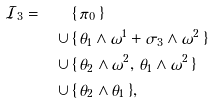<formula> <loc_0><loc_0><loc_500><loc_500>\mathcal { I } _ { 3 } = \, \quad & \{ \, \pi _ { 0 } \, \} \\ \cup \, & \{ \, \theta _ { 1 } \wedge \omega ^ { 1 } + \sigma _ { 3 } \wedge \omega ^ { 2 } \, \} \\ \cup \, & \{ \, \theta _ { 2 } \wedge \omega ^ { 2 } , \, \theta _ { 1 } \wedge \omega ^ { 2 } \, \} \\ \cup \, & \{ \, \theta _ { 2 } \wedge \theta _ { 1 } \, \} ,</formula> 